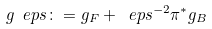Convert formula to latex. <formula><loc_0><loc_0><loc_500><loc_500>g _ { \ } e p s \colon = g _ { F } + \ e p s ^ { - 2 } \pi ^ { * } g _ { B }</formula> 